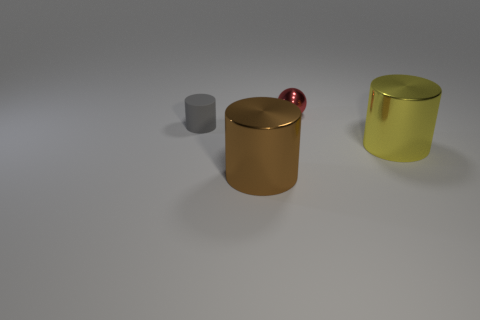Add 1 small red balls. How many objects exist? 5 Subtract all green cylinders. How many purple spheres are left? 0 Subtract all tiny rubber cylinders. Subtract all large yellow objects. How many objects are left? 2 Add 3 big brown cylinders. How many big brown cylinders are left? 4 Add 3 large brown cylinders. How many large brown cylinders exist? 4 Subtract all gray cylinders. How many cylinders are left? 2 Subtract all brown metal cylinders. How many cylinders are left? 2 Subtract 0 purple cubes. How many objects are left? 4 Subtract all cylinders. How many objects are left? 1 Subtract 1 spheres. How many spheres are left? 0 